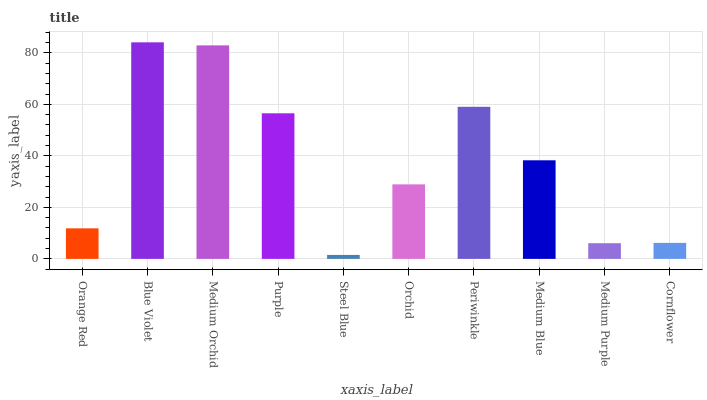Is Steel Blue the minimum?
Answer yes or no. Yes. Is Blue Violet the maximum?
Answer yes or no. Yes. Is Medium Orchid the minimum?
Answer yes or no. No. Is Medium Orchid the maximum?
Answer yes or no. No. Is Blue Violet greater than Medium Orchid?
Answer yes or no. Yes. Is Medium Orchid less than Blue Violet?
Answer yes or no. Yes. Is Medium Orchid greater than Blue Violet?
Answer yes or no. No. Is Blue Violet less than Medium Orchid?
Answer yes or no. No. Is Medium Blue the high median?
Answer yes or no. Yes. Is Orchid the low median?
Answer yes or no. Yes. Is Medium Purple the high median?
Answer yes or no. No. Is Cornflower the low median?
Answer yes or no. No. 